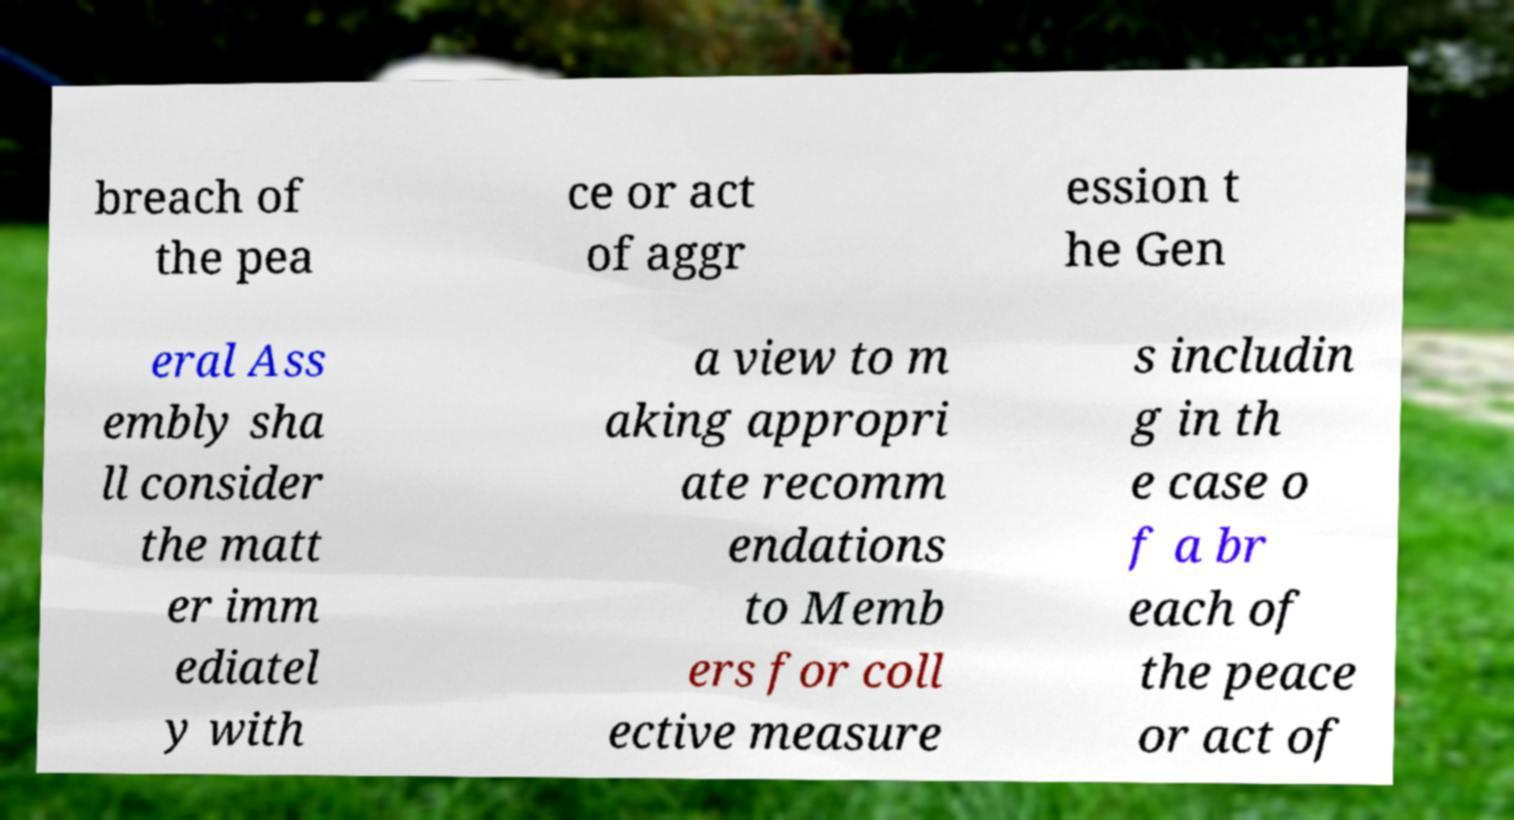Can you read and provide the text displayed in the image?This photo seems to have some interesting text. Can you extract and type it out for me? breach of the pea ce or act of aggr ession t he Gen eral Ass embly sha ll consider the matt er imm ediatel y with a view to m aking appropri ate recomm endations to Memb ers for coll ective measure s includin g in th e case o f a br each of the peace or act of 